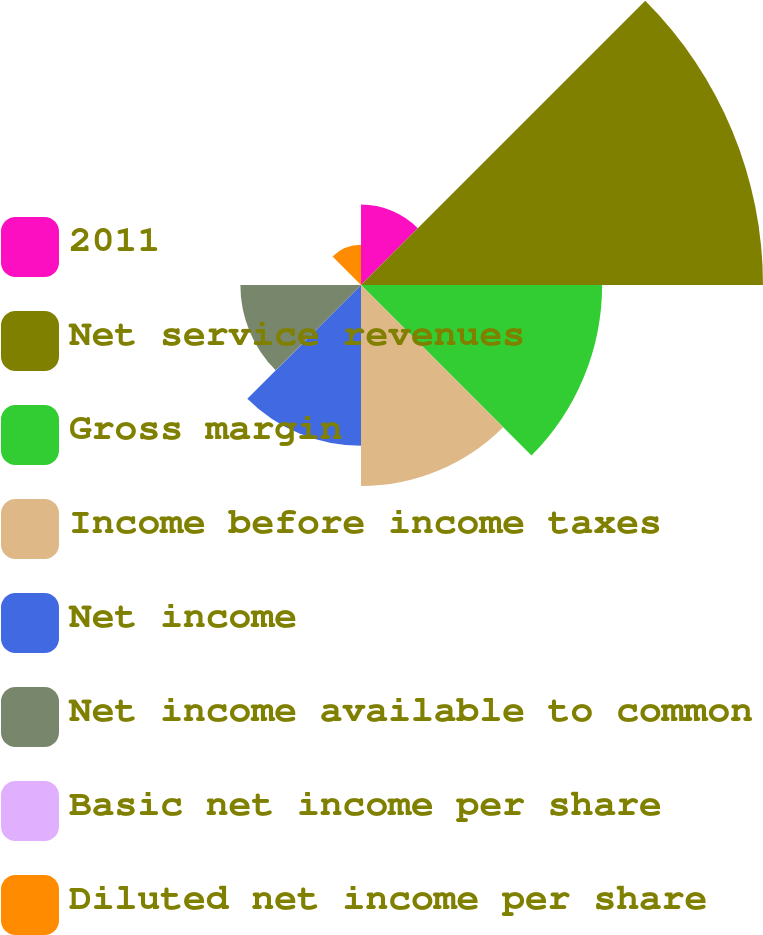<chart> <loc_0><loc_0><loc_500><loc_500><pie_chart><fcel>2011<fcel>Net service revenues<fcel>Gross margin<fcel>Income before income taxes<fcel>Net income<fcel>Net income available to common<fcel>Basic net income per share<fcel>Diluted net income per share<nl><fcel>6.45%<fcel>32.26%<fcel>19.35%<fcel>16.13%<fcel>12.9%<fcel>9.68%<fcel>0.0%<fcel>3.23%<nl></chart> 